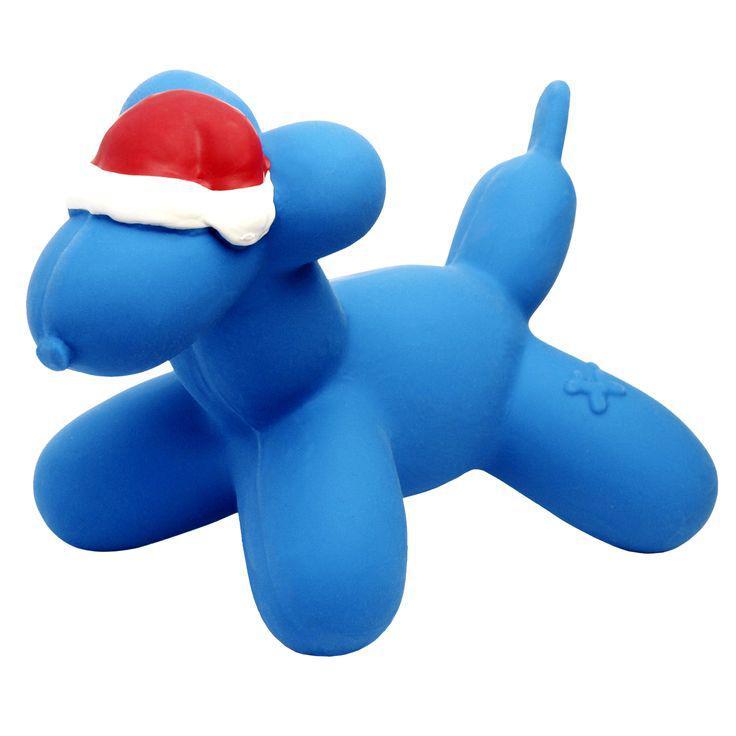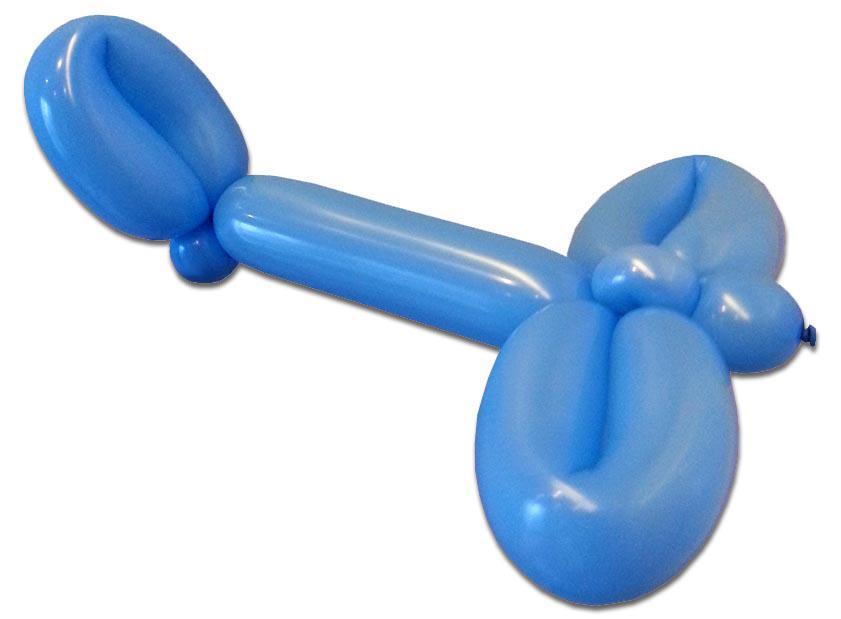The first image is the image on the left, the second image is the image on the right. Considering the images on both sides, is "Only animal-shaped balloon animals are shown." valid? Answer yes or no. No. 